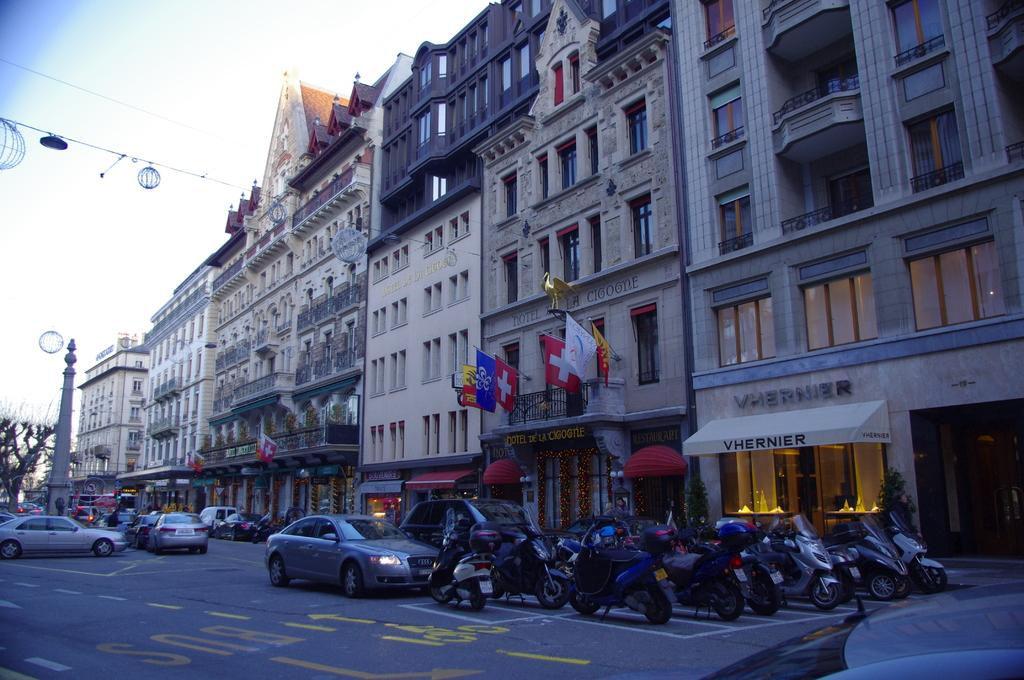What can be seen on the road in the image? There are vehicles on the road in the image. What type of structures are present in the image? There are buildings in the image. What decorative elements can be seen in the image? There are flags in the image. What type of vegetation is visible in the image? There are plants in the image. What is visible in the background of the image? There is a tower, a tree, and the sky visible in the background. How many balls are rolling on the grass in the image? There are no balls or grass present in the image. What type of trains can be seen passing by in the image? There are no trains visible in the image. 